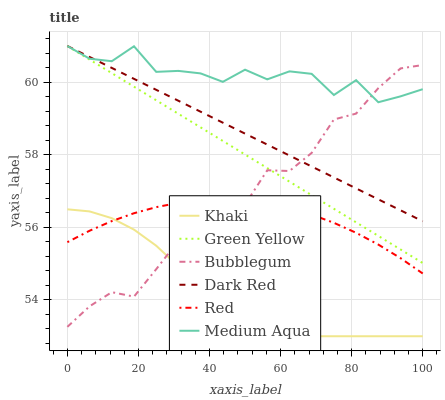Does Khaki have the minimum area under the curve?
Answer yes or no. Yes. Does Medium Aqua have the maximum area under the curve?
Answer yes or no. Yes. Does Dark Red have the minimum area under the curve?
Answer yes or no. No. Does Dark Red have the maximum area under the curve?
Answer yes or no. No. Is Dark Red the smoothest?
Answer yes or no. Yes. Is Medium Aqua the roughest?
Answer yes or no. Yes. Is Bubblegum the smoothest?
Answer yes or no. No. Is Bubblegum the roughest?
Answer yes or no. No. Does Dark Red have the lowest value?
Answer yes or no. No. Does Green Yellow have the highest value?
Answer yes or no. Yes. Does Bubblegum have the highest value?
Answer yes or no. No. Is Red less than Green Yellow?
Answer yes or no. Yes. Is Green Yellow greater than Red?
Answer yes or no. Yes. Does Green Yellow intersect Dark Red?
Answer yes or no. Yes. Is Green Yellow less than Dark Red?
Answer yes or no. No. Is Green Yellow greater than Dark Red?
Answer yes or no. No. Does Red intersect Green Yellow?
Answer yes or no. No. 